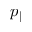<formula> <loc_0><loc_0><loc_500><loc_500>p _ { \| }</formula> 